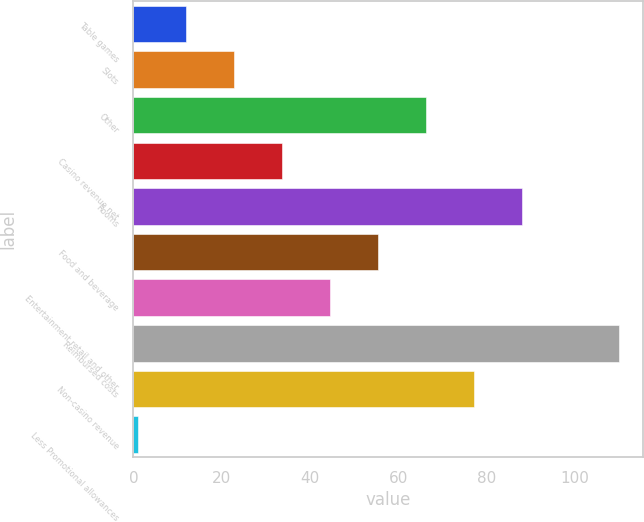<chart> <loc_0><loc_0><loc_500><loc_500><bar_chart><fcel>Table games<fcel>Slots<fcel>Other<fcel>Casino revenue net<fcel>Rooms<fcel>Food and beverage<fcel>Entertainment retail and other<fcel>Reimbursed costs<fcel>Non-casino revenue<fcel>Less Promotional allowances<nl><fcel>11.9<fcel>22.8<fcel>66.4<fcel>33.7<fcel>88.2<fcel>55.5<fcel>44.6<fcel>110<fcel>77.3<fcel>1<nl></chart> 